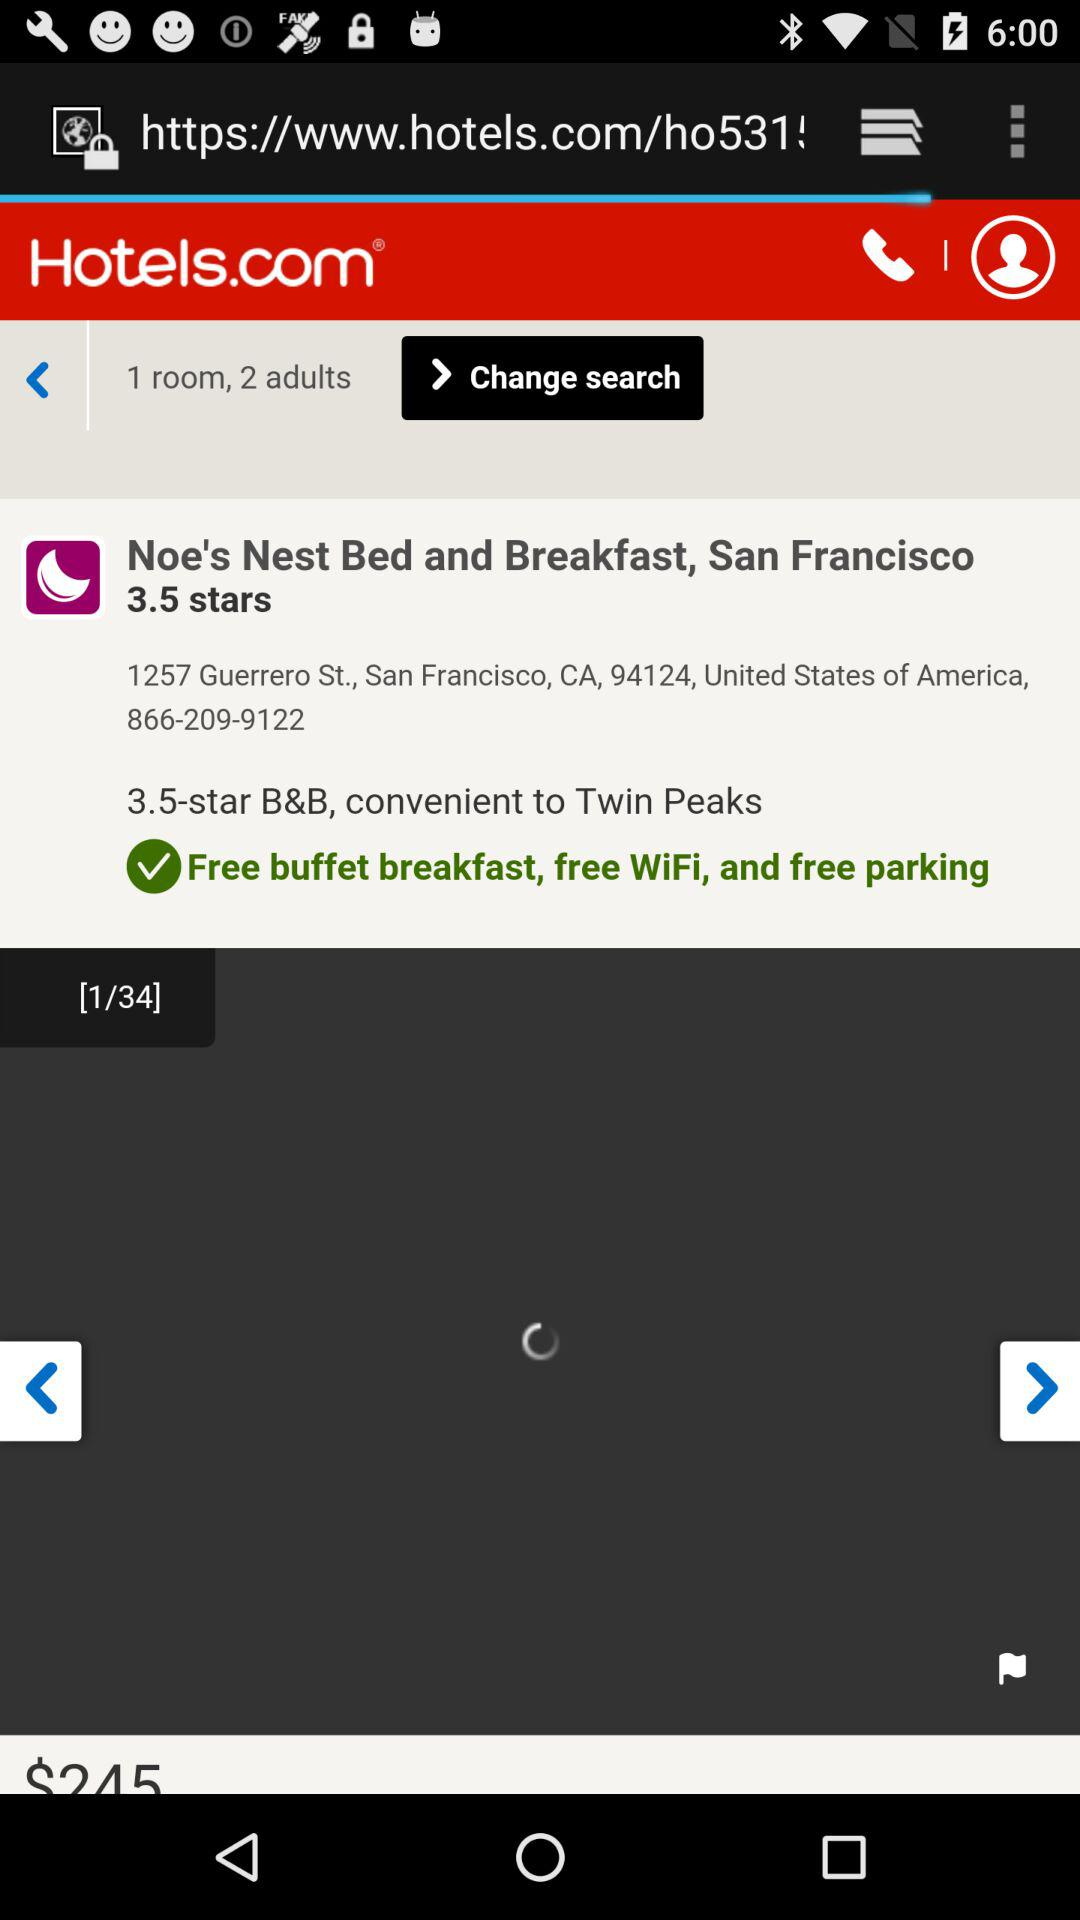What is the address of the hotel Noe's Nest Bed and Breakfast, San Francisco? The address of the hotel is 1257 Guerrero St., San Francisco, CA, 94124, United States of America. 